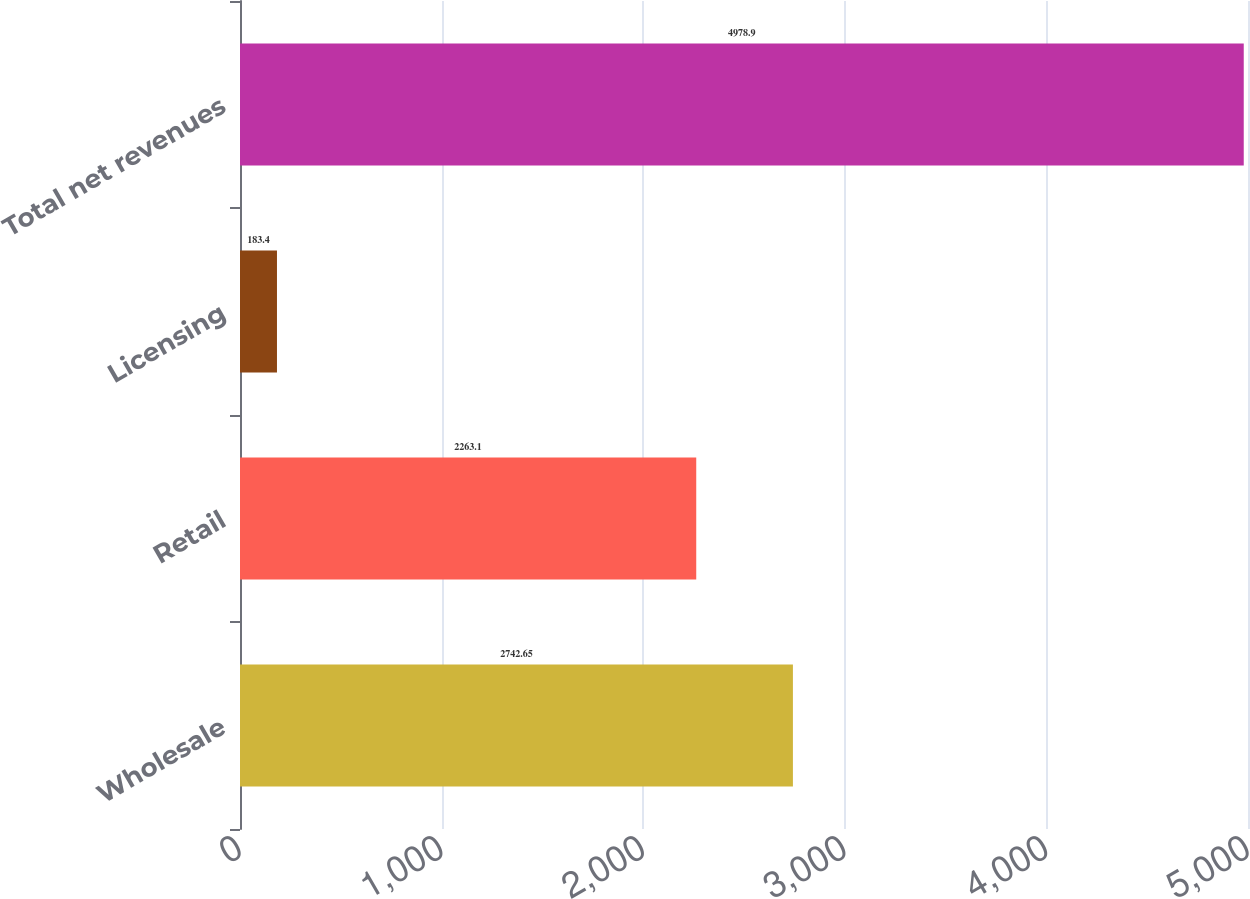<chart> <loc_0><loc_0><loc_500><loc_500><bar_chart><fcel>Wholesale<fcel>Retail<fcel>Licensing<fcel>Total net revenues<nl><fcel>2742.65<fcel>2263.1<fcel>183.4<fcel>4978.9<nl></chart> 